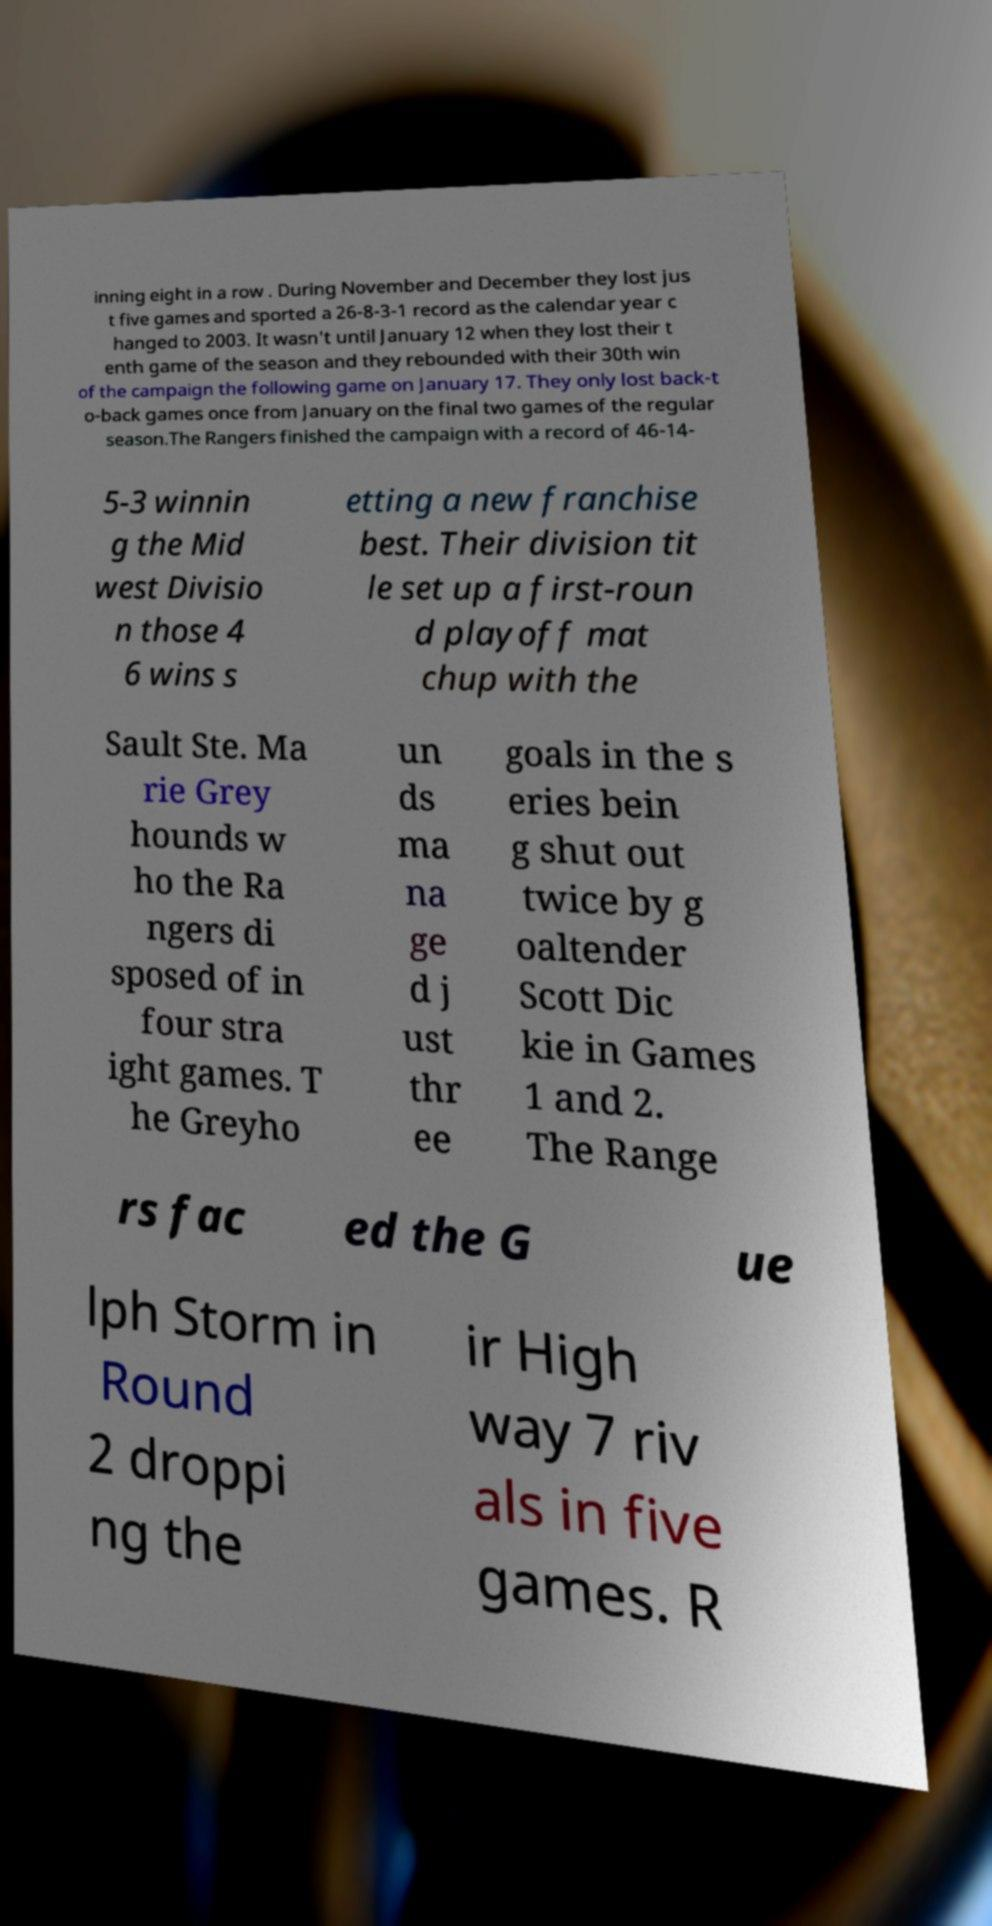Can you read and provide the text displayed in the image?This photo seems to have some interesting text. Can you extract and type it out for me? inning eight in a row . During November and December they lost jus t five games and sported a 26-8-3-1 record as the calendar year c hanged to 2003. It wasn't until January 12 when they lost their t enth game of the season and they rebounded with their 30th win of the campaign the following game on January 17. They only lost back-t o-back games once from January on the final two games of the regular season.The Rangers finished the campaign with a record of 46-14- 5-3 winnin g the Mid west Divisio n those 4 6 wins s etting a new franchise best. Their division tit le set up a first-roun d playoff mat chup with the Sault Ste. Ma rie Grey hounds w ho the Ra ngers di sposed of in four stra ight games. T he Greyho un ds ma na ge d j ust thr ee goals in the s eries bein g shut out twice by g oaltender Scott Dic kie in Games 1 and 2. The Range rs fac ed the G ue lph Storm in Round 2 droppi ng the ir High way 7 riv als in five games. R 